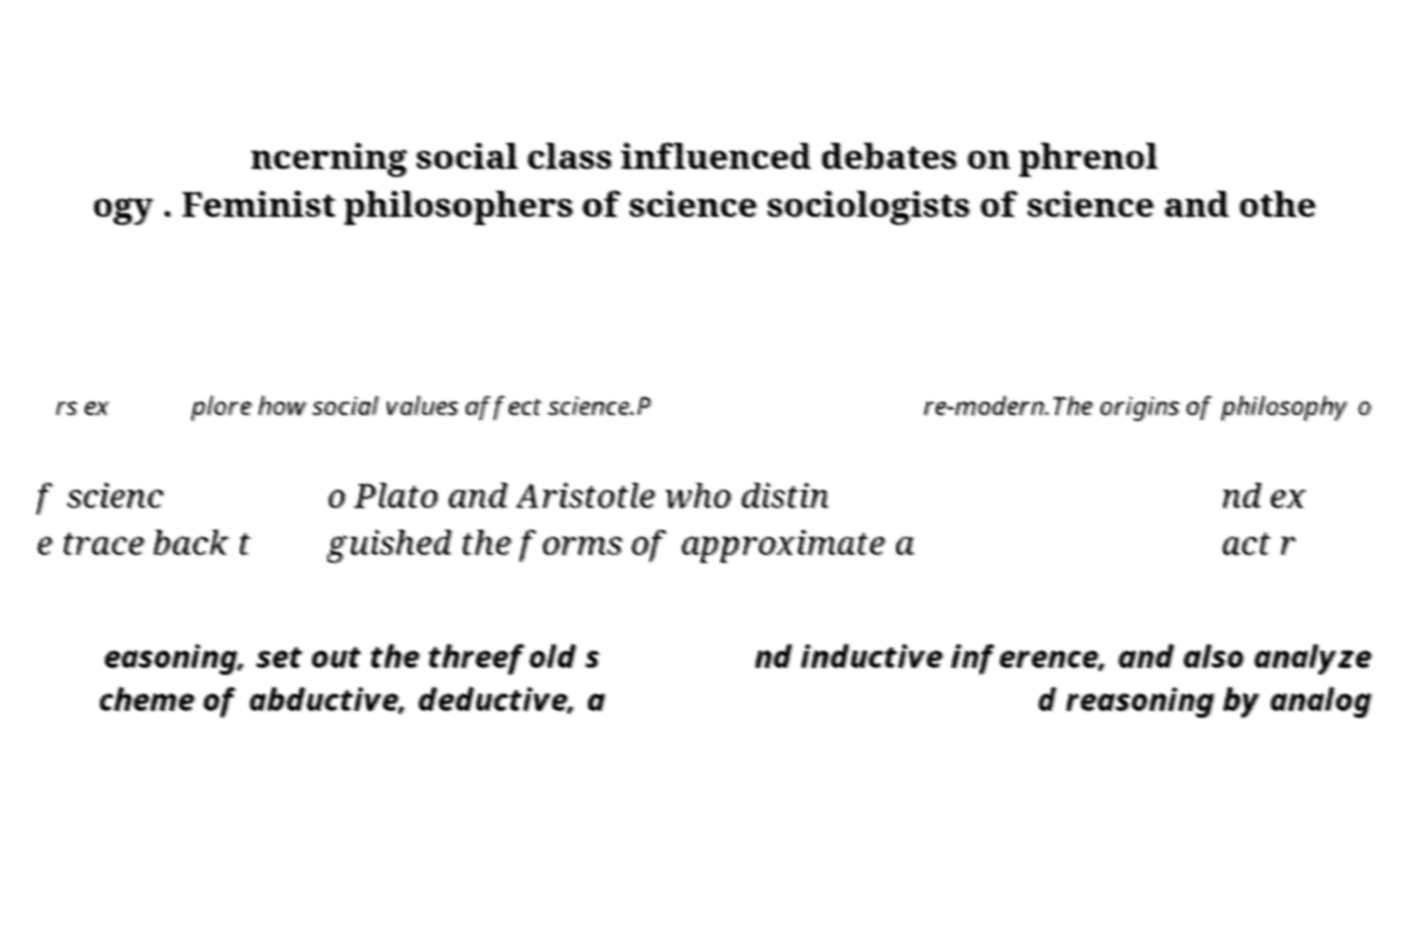What messages or text are displayed in this image? I need them in a readable, typed format. ncerning social class influenced debates on phrenol ogy . Feminist philosophers of science sociologists of science and othe rs ex plore how social values affect science.P re-modern.The origins of philosophy o f scienc e trace back t o Plato and Aristotle who distin guished the forms of approximate a nd ex act r easoning, set out the threefold s cheme of abductive, deductive, a nd inductive inference, and also analyze d reasoning by analog 